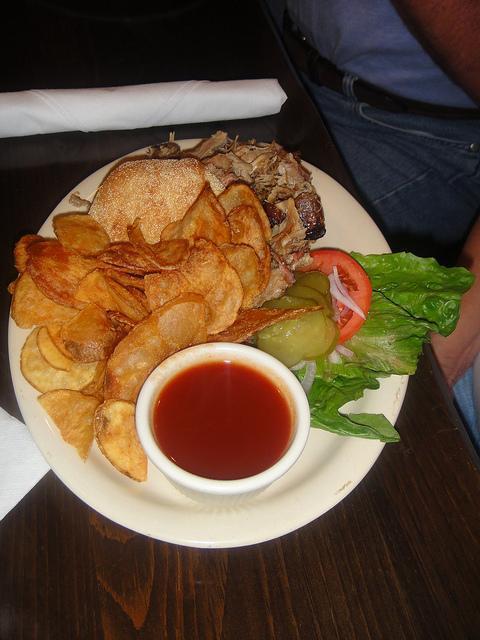How many sandwiches are in the picture?
Give a very brief answer. 1. How many bowls are there?
Give a very brief answer. 1. 